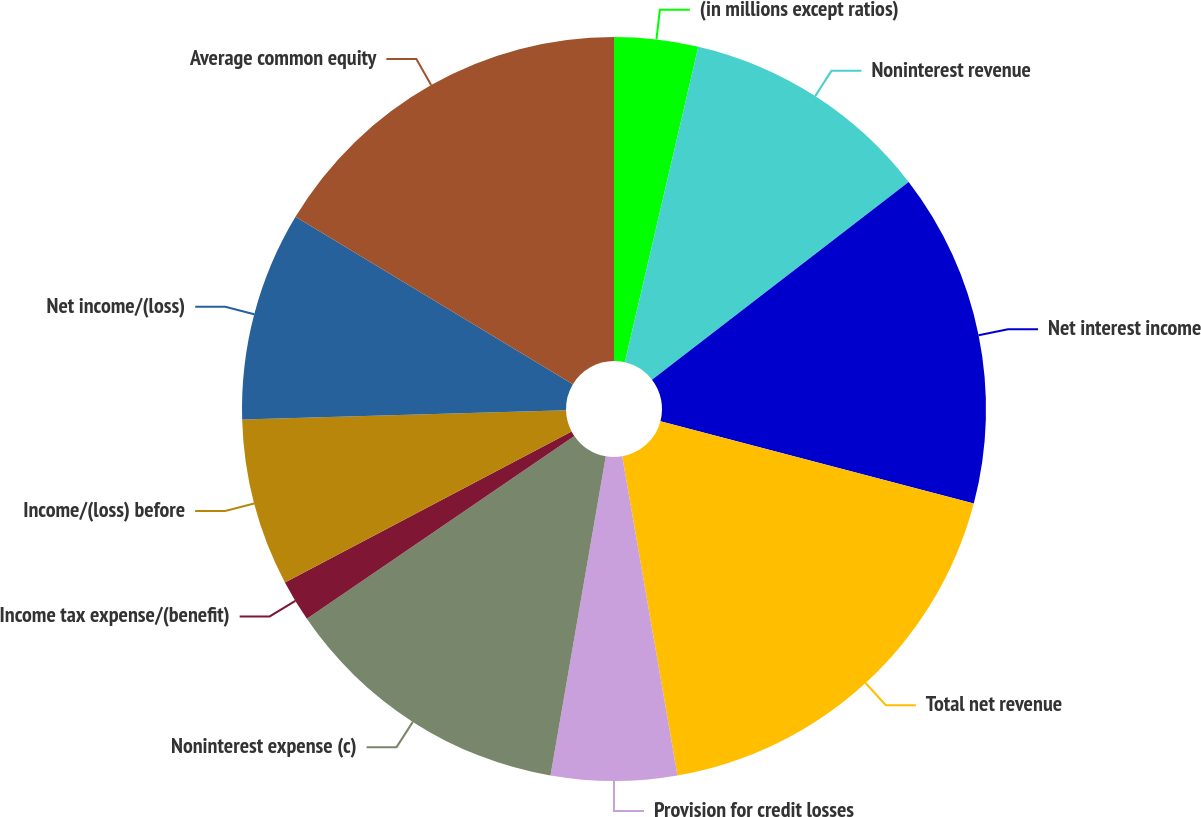<chart> <loc_0><loc_0><loc_500><loc_500><pie_chart><fcel>(in millions except ratios)<fcel>Noninterest revenue<fcel>Net interest income<fcel>Total net revenue<fcel>Provision for credit losses<fcel>Noninterest expense (c)<fcel>Income tax expense/(benefit)<fcel>Income/(loss) before<fcel>Net income/(loss)<fcel>Average common equity<nl><fcel>3.64%<fcel>10.91%<fcel>14.54%<fcel>18.18%<fcel>5.46%<fcel>12.73%<fcel>1.82%<fcel>7.27%<fcel>9.09%<fcel>16.36%<nl></chart> 